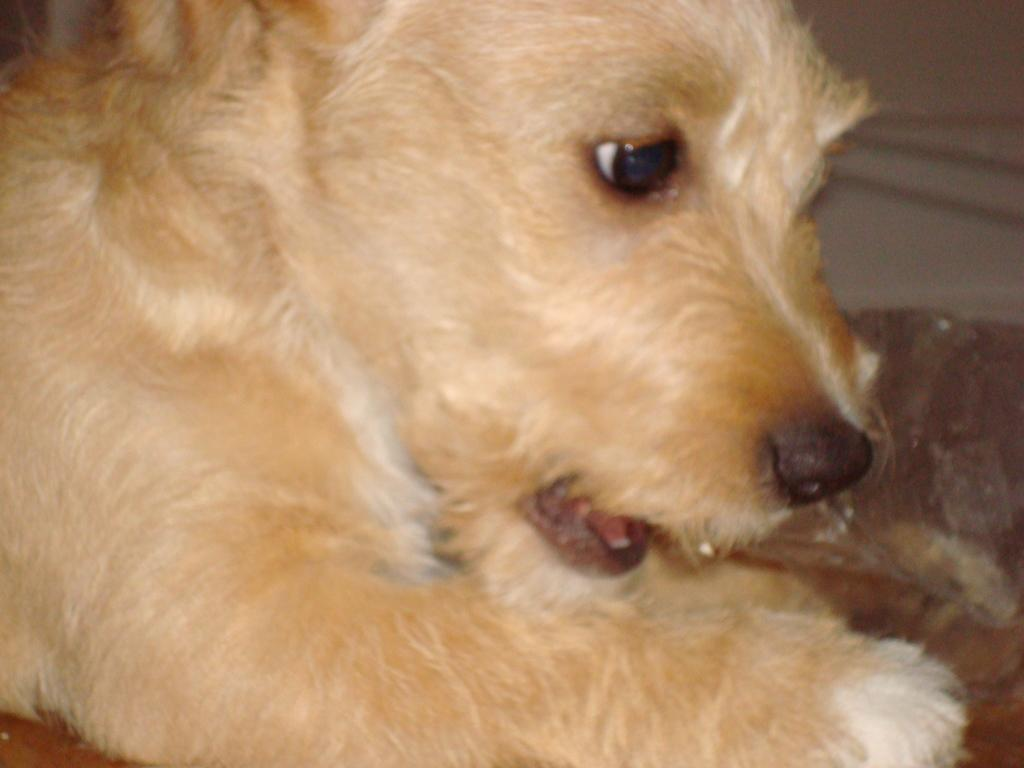What type of animal is present in the image? There is a dog in the image. Can you describe the dog's appearance? The dog is cream-colored. How many pizzas are being served to the dog in the image? There are no pizzas present in the image; it features a dog. What type of health advice can be given to the dog in the image? There is no specific health advice that can be given based on the information provided in the image. 